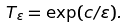Convert formula to latex. <formula><loc_0><loc_0><loc_500><loc_500>T _ { \varepsilon } = \exp ( c / \varepsilon ) .</formula> 